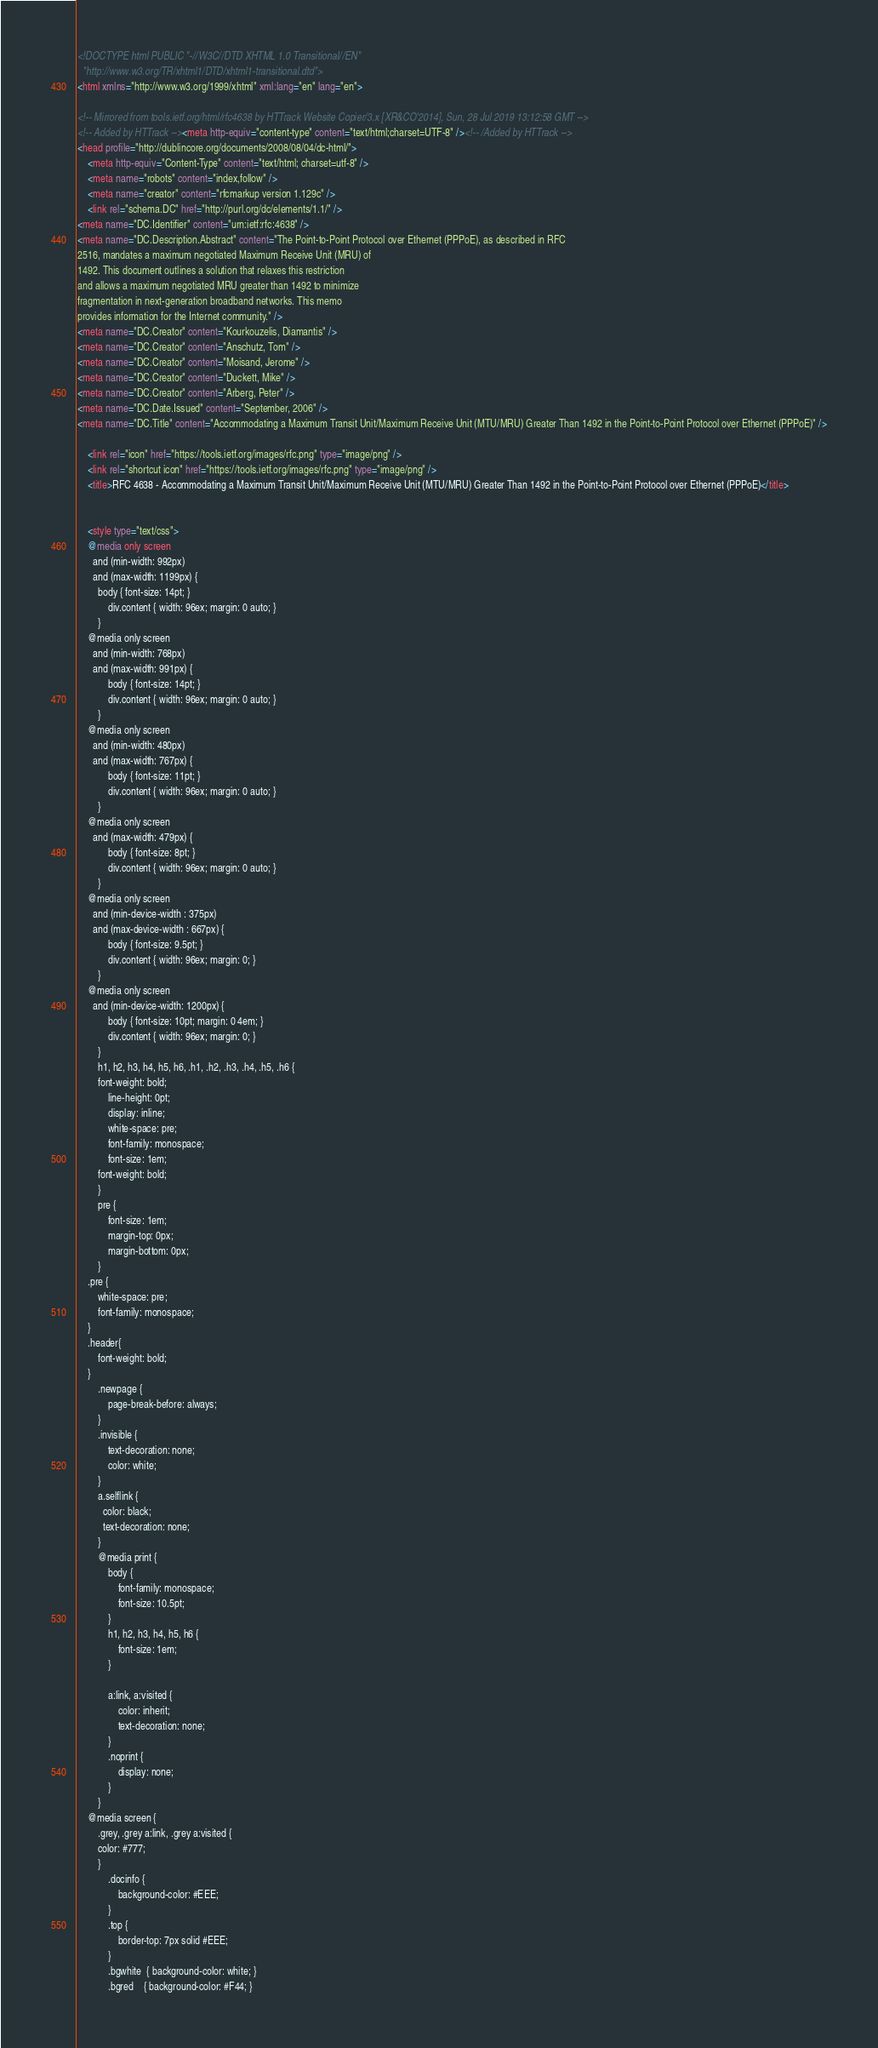Convert code to text. <code><loc_0><loc_0><loc_500><loc_500><_HTML_><!DOCTYPE html PUBLIC "-//W3C//DTD XHTML 1.0 Transitional//EN"
  "http://www.w3.org/TR/xhtml1/DTD/xhtml1-transitional.dtd">
<html xmlns="http://www.w3.org/1999/xhtml" xml:lang="en" lang="en">

<!-- Mirrored from tools.ietf.org/html/rfc4638 by HTTrack Website Copier/3.x [XR&CO'2014], Sun, 28 Jul 2019 13:12:58 GMT -->
<!-- Added by HTTrack --><meta http-equiv="content-type" content="text/html;charset=UTF-8" /><!-- /Added by HTTrack -->
<head profile="http://dublincore.org/documents/2008/08/04/dc-html/">
    <meta http-equiv="Content-Type" content="text/html; charset=utf-8" />
    <meta name="robots" content="index,follow" />
    <meta name="creator" content="rfcmarkup version 1.129c" />
    <link rel="schema.DC" href="http://purl.org/dc/elements/1.1/" />
<meta name="DC.Identifier" content="urn:ietf:rfc:4638" />
<meta name="DC.Description.Abstract" content="The Point-to-Point Protocol over Ethernet (PPPoE), as described in RFC
2516, mandates a maximum negotiated Maximum Receive Unit (MRU) of
1492. This document outlines a solution that relaxes this restriction
and allows a maximum negotiated MRU greater than 1492 to minimize
fragmentation in next-generation broadband networks. This memo
provides information for the Internet community." />
<meta name="DC.Creator" content="Kourkouzelis, Diamantis" />
<meta name="DC.Creator" content="Anschutz, Tom" />
<meta name="DC.Creator" content="Moisand, Jerome" />
<meta name="DC.Creator" content="Duckett, Mike" />
<meta name="DC.Creator" content="Arberg, Peter" />
<meta name="DC.Date.Issued" content="September, 2006" />
<meta name="DC.Title" content="Accommodating a Maximum Transit Unit/Maximum Receive Unit (MTU/MRU) Greater Than 1492 in the Point-to-Point Protocol over Ethernet (PPPoE)" />

    <link rel="icon" href="https://tools.ietf.org/images/rfc.png" type="image/png" />
    <link rel="shortcut icon" href="https://tools.ietf.org/images/rfc.png" type="image/png" />
    <title>RFC 4638 - Accommodating a Maximum Transit Unit/Maximum Receive Unit (MTU/MRU) Greater Than 1492 in the Point-to-Point Protocol over Ethernet (PPPoE)</title>
    
    
    <style type="text/css">
	@media only screen 
	  and (min-width: 992px)
	  and (max-width: 1199px) {
	    body { font-size: 14pt; }
            div.content { width: 96ex; margin: 0 auto; }
        }
	@media only screen 
	  and (min-width: 768px)
	  and (max-width: 991px) {
            body { font-size: 14pt; }
            div.content { width: 96ex; margin: 0 auto; }
        }
	@media only screen 
	  and (min-width: 480px)
	  and (max-width: 767px) {
            body { font-size: 11pt; }
            div.content { width: 96ex; margin: 0 auto; }
        }
	@media only screen 
	  and (max-width: 479px) {
            body { font-size: 8pt; }
            div.content { width: 96ex; margin: 0 auto; }
        }
	@media only screen 
	  and (min-device-width : 375px) 
	  and (max-device-width : 667px) {
            body { font-size: 9.5pt; }
            div.content { width: 96ex; margin: 0; }
        }
	@media only screen 
	  and (min-device-width: 1200px) {
            body { font-size: 10pt; margin: 0 4em; }
            div.content { width: 96ex; margin: 0; }
        }
        h1, h2, h3, h4, h5, h6, .h1, .h2, .h3, .h4, .h5, .h6 {
	    font-weight: bold;
            line-height: 0pt;
            display: inline;
            white-space: pre;
            font-family: monospace;
            font-size: 1em;
	    font-weight: bold;
        }
        pre {
            font-size: 1em;
            margin-top: 0px;
            margin-bottom: 0px;
        }
	.pre {
	    white-space: pre;
	    font-family: monospace;
	}
	.header{
	    font-weight: bold;
	}
        .newpage {
            page-break-before: always;
        }
        .invisible {
            text-decoration: none;
            color: white;
        }
        a.selflink {
          color: black;
          text-decoration: none;
        }
        @media print {
            body {
                font-family: monospace;
                font-size: 10.5pt;
            }
            h1, h2, h3, h4, h5, h6 {
                font-size: 1em;
            }
        
            a:link, a:visited {
                color: inherit;
                text-decoration: none;
            }
            .noprint {
                display: none;
            }
        }
	@media screen {
	    .grey, .grey a:link, .grey a:visited {
		color: #777;
	    }
            .docinfo {
                background-color: #EEE;
            }
            .top {
                border-top: 7px solid #EEE;
            }
            .bgwhite  { background-color: white; }
            .bgred    { background-color: #F44; }</code> 